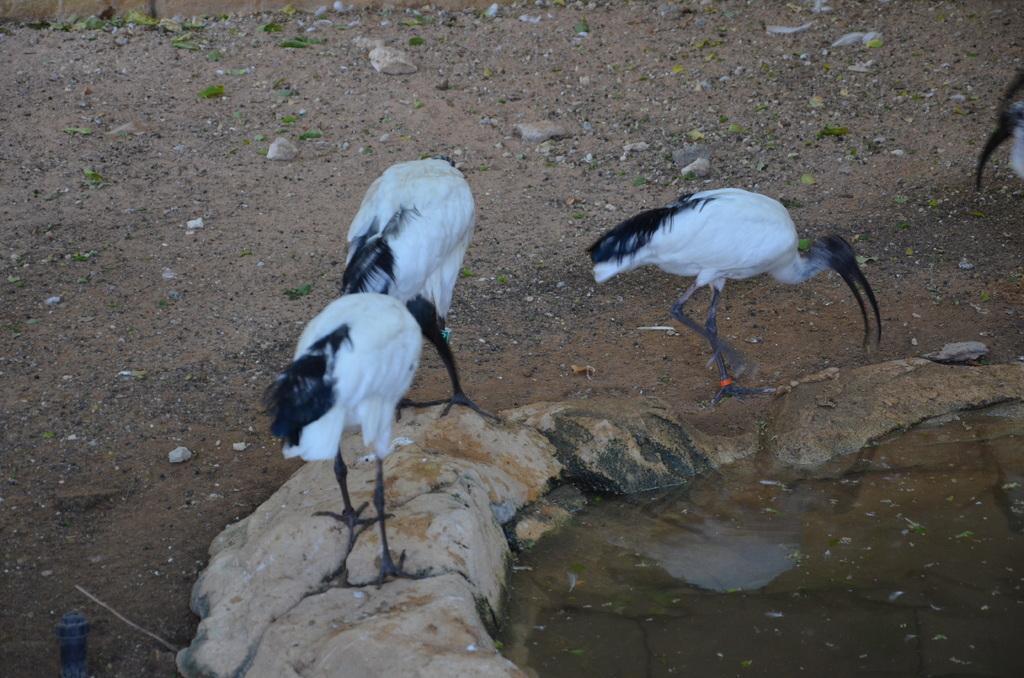In one or two sentences, can you explain what this image depicts? In the image we can see there are birds, white and black in color. Here we can see water, stones and sand. 